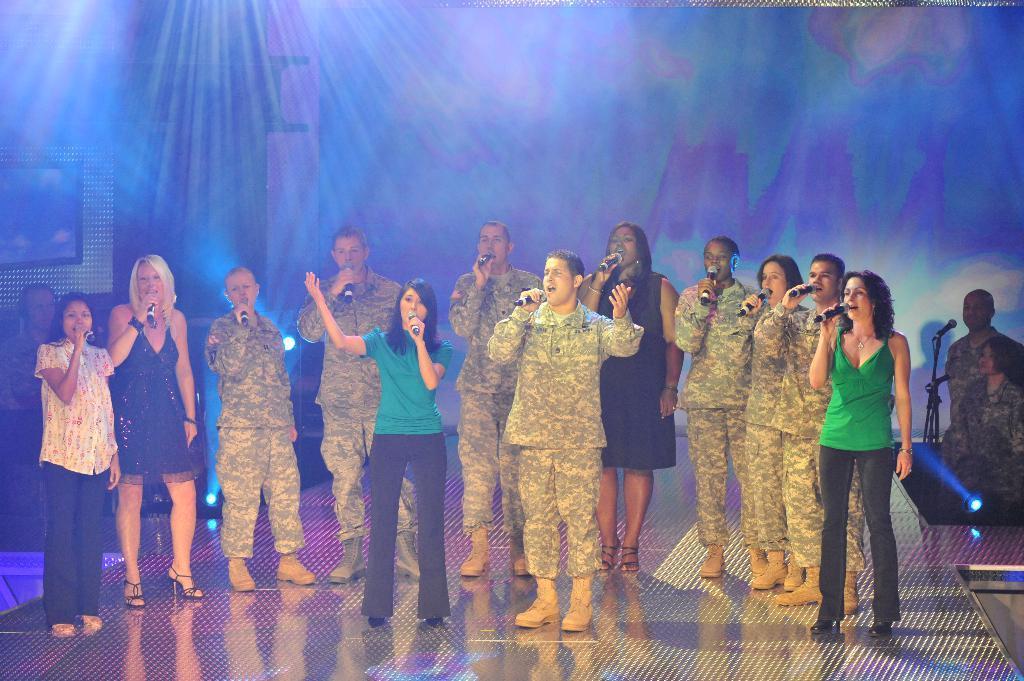In one or two sentences, can you explain what this image depicts? In the center of the image a group of people are standing on stage and holding mic and singing. In the background of the image we can see lights are there. On the right side of the image two persons are standing, in-front of them mic and stand are there. 